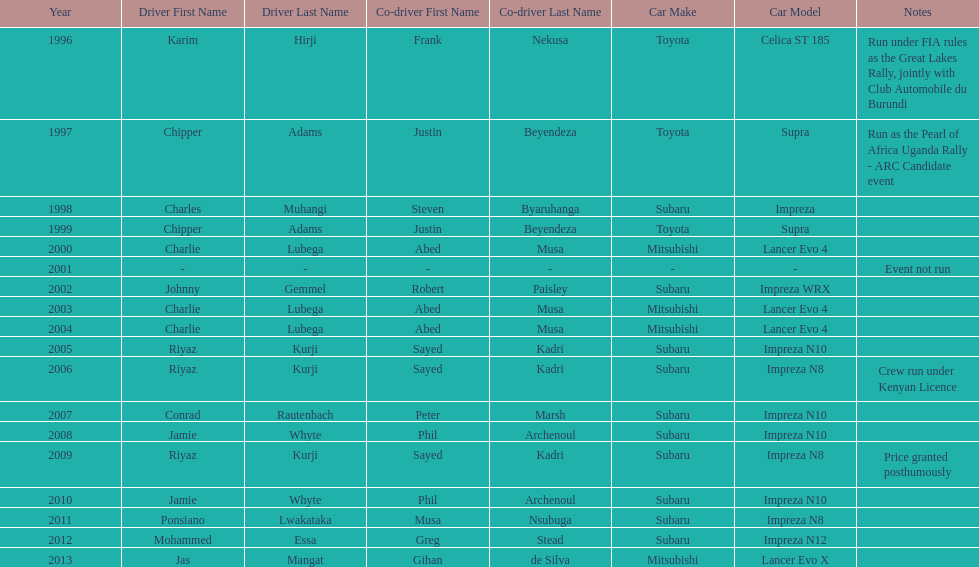How many drivers are racing with a co-driver from a different country? 1. 